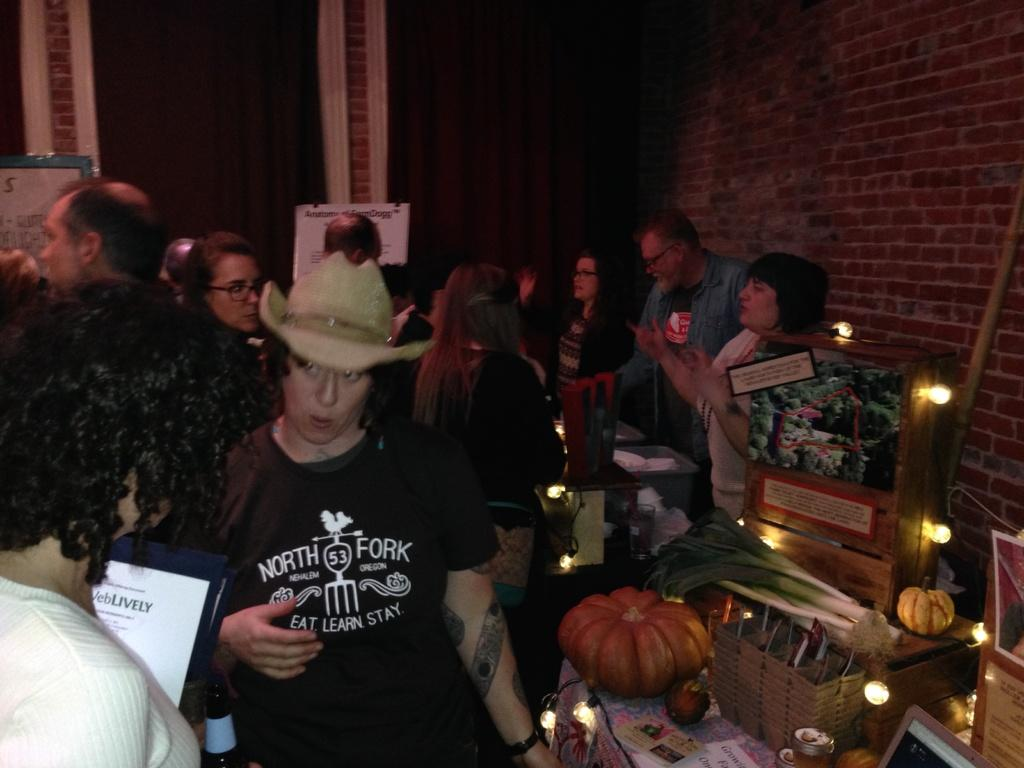How many people are in the image? There are people in the image, but the exact number is not specified. What is one person wearing in the image? One person is wearing a cap in the image. What is on the table in the image? There is a pumpkin on the table in the image, as well as other unspecified things. What type of furniture is present in the image? There is a table in the image. What type of pet is sitting next to the pumpkin on the table? There is no pet present in the image; only people, a cap, a table, a pumpkin, and other unspecified items are visible. 